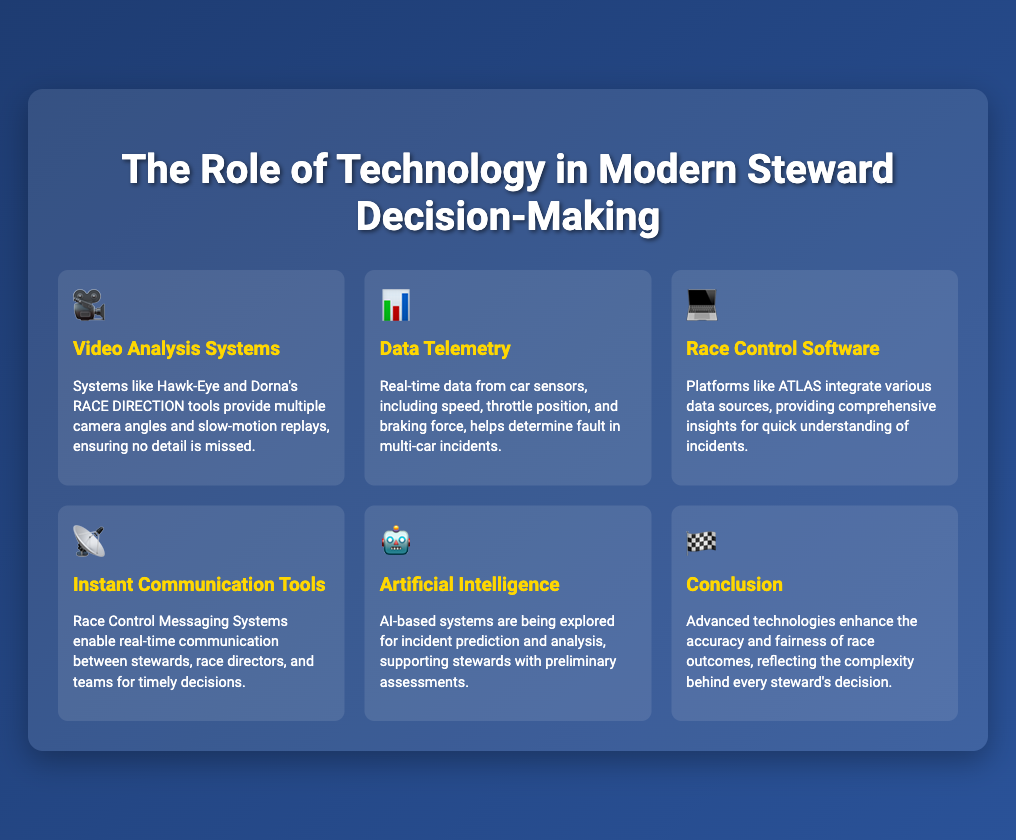What systems provide multiple camera angles and slow-motion replays? The document mentions systems like Hawk-Eye and Dorna's RACE DIRECTION tools for video analysis.
Answer: Hawk-Eye, Dorna's RACE DIRECTION tools What type of data helps determine fault in multi-car incidents? The document states that real-time data from car sensors, including speed and throttle position, assists in determining fault.
Answer: Data from car sensors Which software integrates various data sources for race control? The document specifies that platforms like ATLAS are used for integrating data sources in race control.
Answer: ATLAS What technology enables real-time communication among race officials? The document mentions Race Control Messaging Systems as the technology for real-time communication.
Answer: Race Control Messaging Systems What role does artificial intelligence play in steward decision-making? According to the document, AI-based systems assist with incident prediction and analysis for preliminary assessments.
Answer: Incident prediction and analysis How do advanced technologies impact race outcomes according to the document? The document concludes that advanced technologies enhance accuracy and fairness of race outcomes.
Answer: Accuracy and fairness 